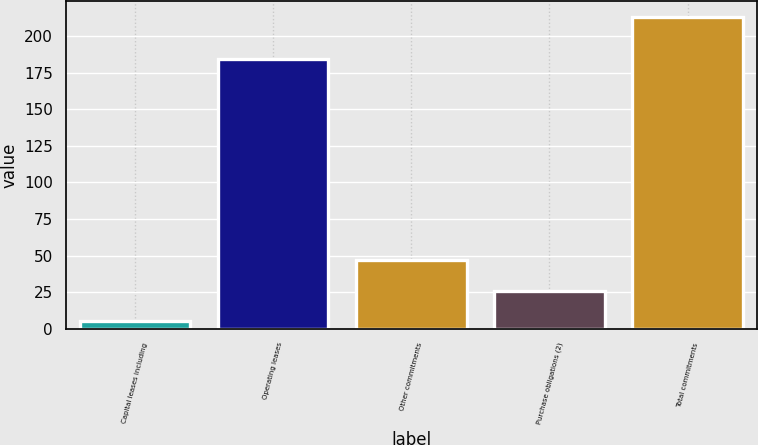Convert chart. <chart><loc_0><loc_0><loc_500><loc_500><bar_chart><fcel>Capital leases including<fcel>Operating leases<fcel>Other commitments<fcel>Purchase obligations (2)<fcel>Total commitments<nl><fcel>5<fcel>184<fcel>46.6<fcel>25.8<fcel>213<nl></chart> 